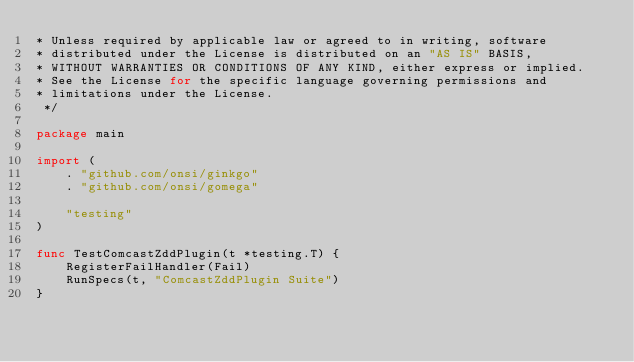<code> <loc_0><loc_0><loc_500><loc_500><_Go_>* Unless required by applicable law or agreed to in writing, software
* distributed under the License is distributed on an "AS IS" BASIS,
* WITHOUT WARRANTIES OR CONDITIONS OF ANY KIND, either express or implied.
* See the License for the specific language governing permissions and
* limitations under the License.
 */

package main

import (
	. "github.com/onsi/ginkgo"
	. "github.com/onsi/gomega"

	"testing"
)

func TestComcastZddPlugin(t *testing.T) {
	RegisterFailHandler(Fail)
	RunSpecs(t, "ComcastZddPlugin Suite")
}
</code> 